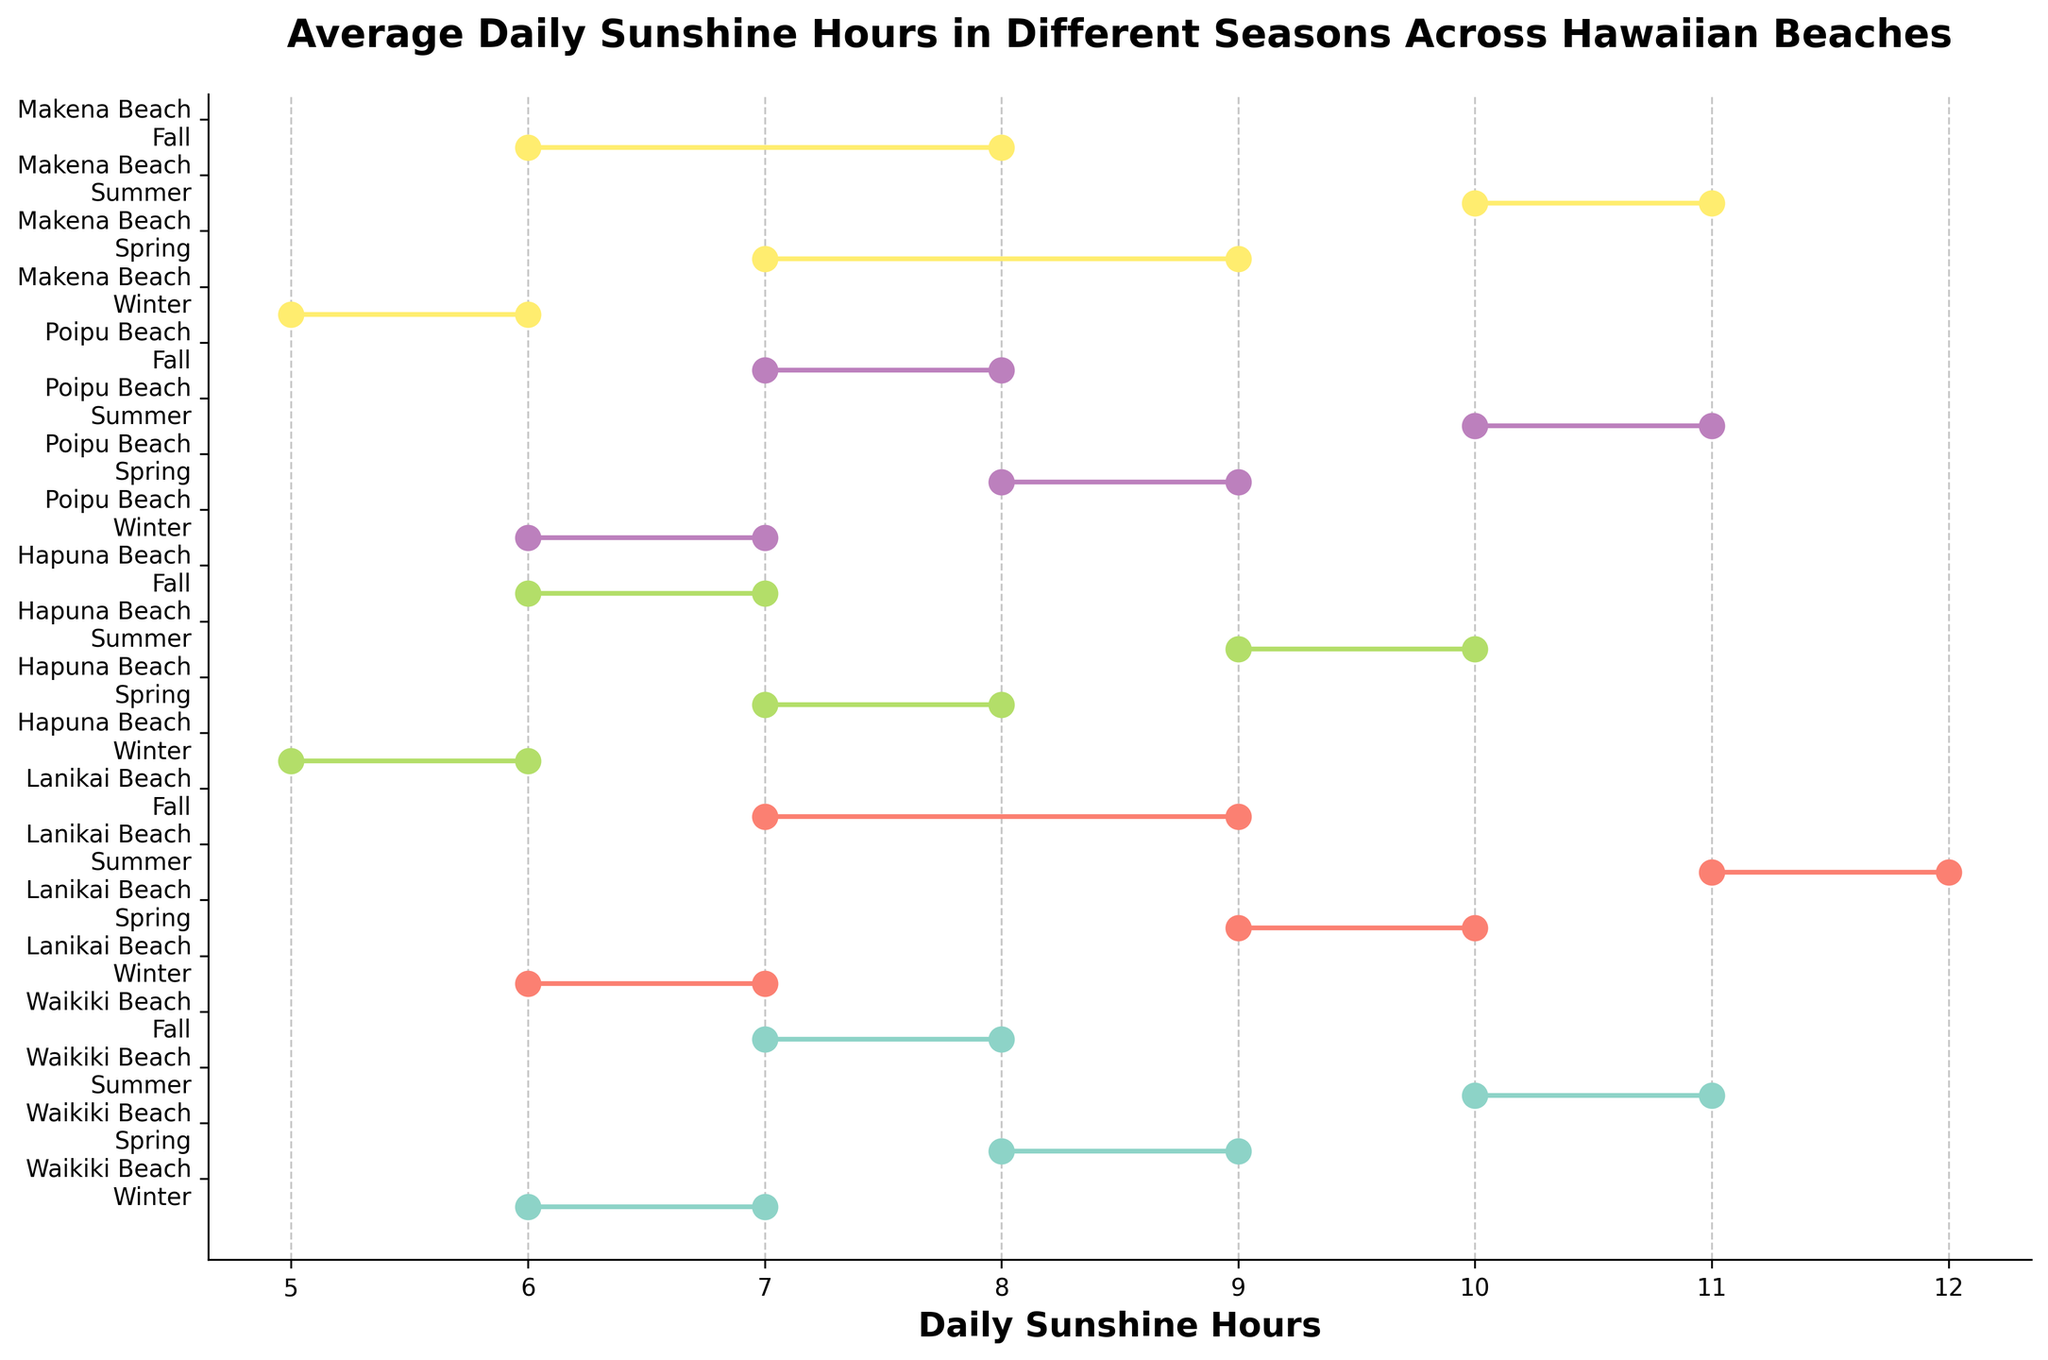What's the title of the plot? The title is located at the top center of the plot. It is usually in bold font and often gives a summary of what the plot is about.
Answer: Average Daily Sunshine Hours in Different Seasons Across Hawaiian Beaches How many beaches are depicted in the plot? Each beach is represented by a unique set of colored points and lines across different seasons. By counting these sets, you can determine the number of beaches.
Answer: 5 Which beach has the widest range of daily sunshine hours during Spring? To find the widest range, we look for the beach with the largest difference between the minimum and maximum points on the x-axis during the Spring season. Makena Beach ranges from 7 to 9 hours, giving a range of 2 hours; Lanikai Beach ranges from 9 to 10 hours, giving a range of 1 hour; etc.
Answer: Makena Beach In which season does Hapuna Beach have the minimum daily sunshine hours? By examining the lowermost x-axis values (sunshine hours) corresponding to Hapuna Beach in different seasons, we can determine the season with the least sunshine hours.
Answer: Winter Which beach shows the most consistent daily sunshine hours throughout the year? To find the beach with the most consistent sunshine, check for the smallest variations in sunshine hours across all seasons, meaning shorter lines indicating a narrower range. Waikiki Beach shows relatively consistent ranges between the seasons.
Answer: Waikiki Beach Which season has the highest maximum daily sunshine hours for most beaches? Look for the season where the maximum points on the x-axis are highest across different beaches. The maximum points during Summer often fall between 10 and 12 hours, higher than other seasons.
Answer: Summer What is the difference between the maximum and minimum daily sunshine hours for Lanikai Beach during Fall? For Lanikai Beach in Fall, subtract the minimum value (7 hours) from the maximum value (9 hours) to find the difference.
Answer: 2 hours How do the sunshine hours at Poipu Beach compare between Winter and Summer? To compare, inspect the minimum and maximum points for Poipu Beach in Winter (6-7 hours) and Summer (10-11 hours). Summer clearly has higher sunshine hours.
Answer: Summer has more sunshine hours Which beach has the highest minimum daily sunshine hours during Summer? Review the lowest points (minimum) on the x-axis for each beach during Summer. Lanikai Beach’s summer minimum is 11 hours, the highest among all.
Answer: Lanikai Beach 